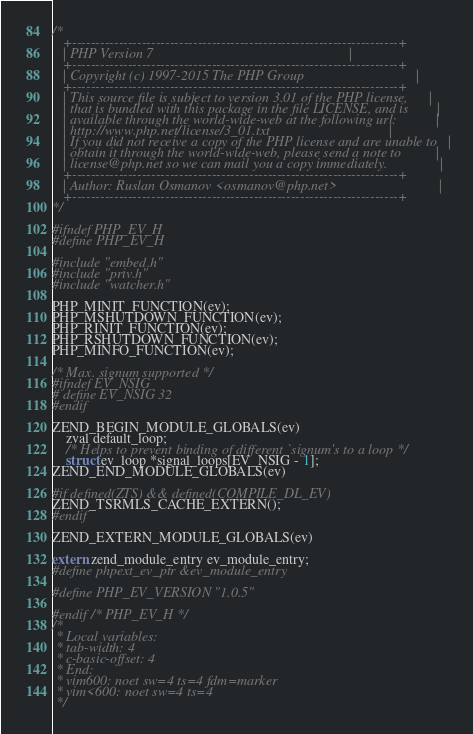<code> <loc_0><loc_0><loc_500><loc_500><_C_>/*
   +----------------------------------------------------------------------+
   | PHP Version 7                                                        |
   +----------------------------------------------------------------------+
   | Copyright (c) 1997-2015 The PHP Group                                |
   +----------------------------------------------------------------------+
   | This source file is subject to version 3.01 of the PHP license,      |
   | that is bundled with this package in the file LICENSE, and is        |
   | available through the world-wide-web at the following url:           |
   | http://www.php.net/license/3_01.txt                                  |
   | If you did not receive a copy of the PHP license and are unable to   |
   | obtain it through the world-wide-web, please send a note to          |
   | license@php.net so we can mail you a copy immediately.               |
   +----------------------------------------------------------------------+
   | Author: Ruslan Osmanov <osmanov@php.net>                             |
   +----------------------------------------------------------------------+
*/

#ifndef PHP_EV_H
#define PHP_EV_H

#include "embed.h"
#include "priv.h"
#include "watcher.h"

PHP_MINIT_FUNCTION(ev);
PHP_MSHUTDOWN_FUNCTION(ev);
PHP_RINIT_FUNCTION(ev);
PHP_RSHUTDOWN_FUNCTION(ev);
PHP_MINFO_FUNCTION(ev);

/* Max. signum supported */
#ifndef EV_NSIG
# define EV_NSIG 32
#endif

ZEND_BEGIN_MODULE_GLOBALS(ev)
	zval default_loop;
	/* Helps to prevent binding of different `signum's to a loop */
	struct ev_loop *signal_loops[EV_NSIG - 1];
ZEND_END_MODULE_GLOBALS(ev)

#if defined(ZTS) && defined(COMPILE_DL_EV)
ZEND_TSRMLS_CACHE_EXTERN();
#endif

ZEND_EXTERN_MODULE_GLOBALS(ev)

extern zend_module_entry ev_module_entry;
#define phpext_ev_ptr &ev_module_entry

#define PHP_EV_VERSION "1.0.5"

#endif /* PHP_EV_H */
/*
 * Local variables:
 * tab-width: 4
 * c-basic-offset: 4
 * End:
 * vim600: noet sw=4 ts=4 fdm=marker
 * vim<600: noet sw=4 ts=4
 */
</code> 